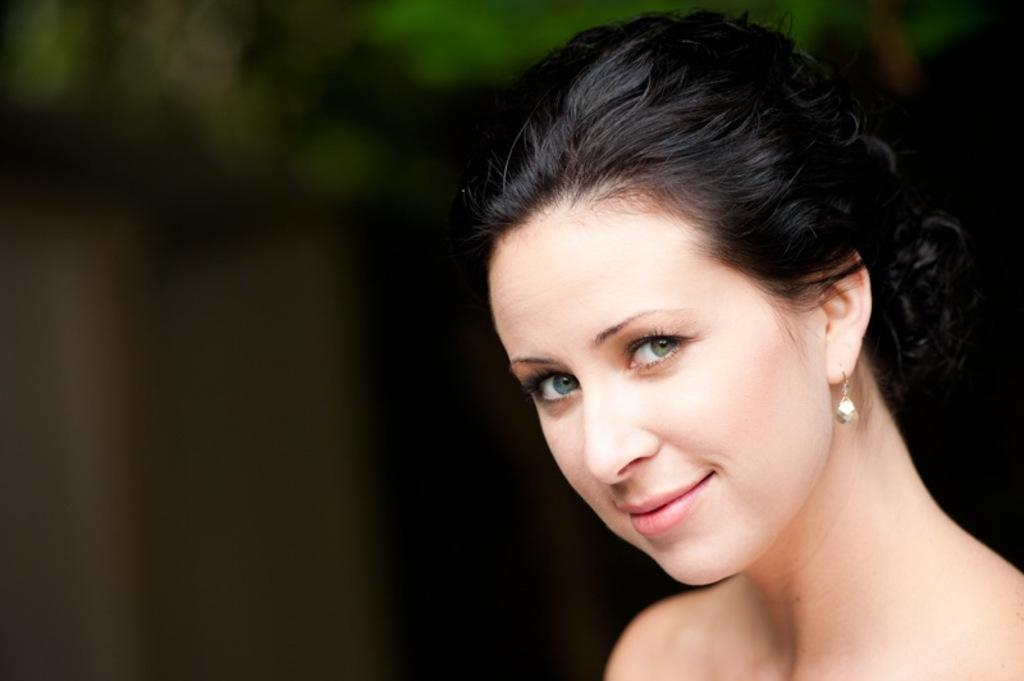Who is present in the image? There is a woman in the image. What is the woman's facial expression? The woman is smiling. What colors can be seen in the background of the image? The background of the image is black and green color. What type of accessory is the woman wearing? The woman is wearing an earring. How many bikes are visible in the image? There are no bikes present in the image. What type of twig is the woman holding in the image? There is no twig present in the image. 